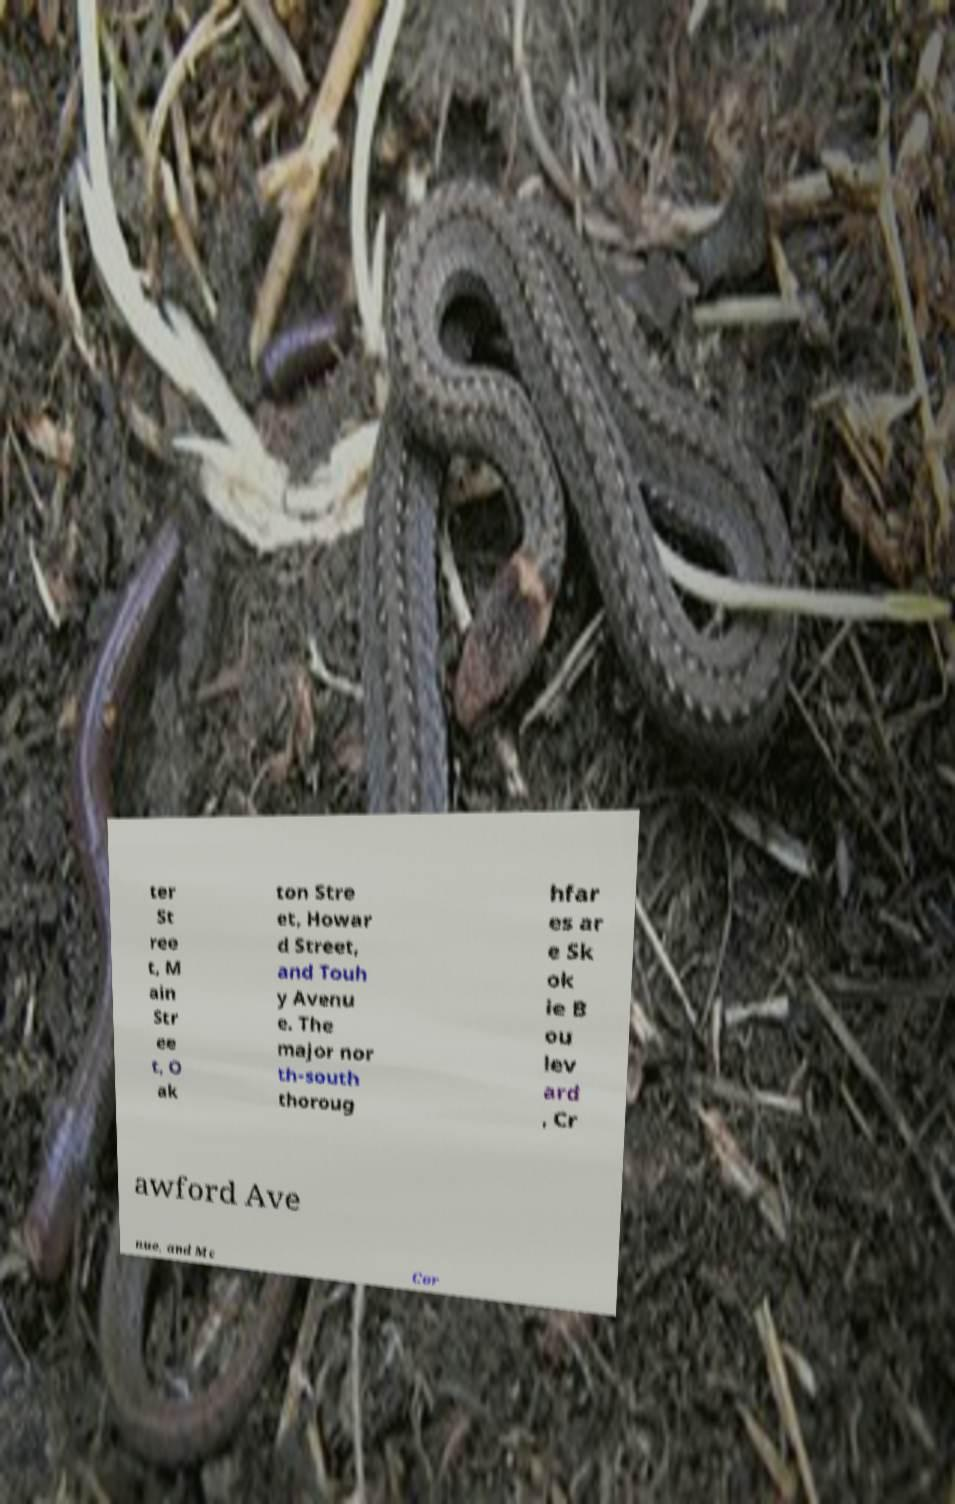What messages or text are displayed in this image? I need them in a readable, typed format. ter St ree t, M ain Str ee t, O ak ton Stre et, Howar d Street, and Touh y Avenu e. The major nor th-south thoroug hfar es ar e Sk ok ie B ou lev ard , Cr awford Ave nue, and Mc Cor 